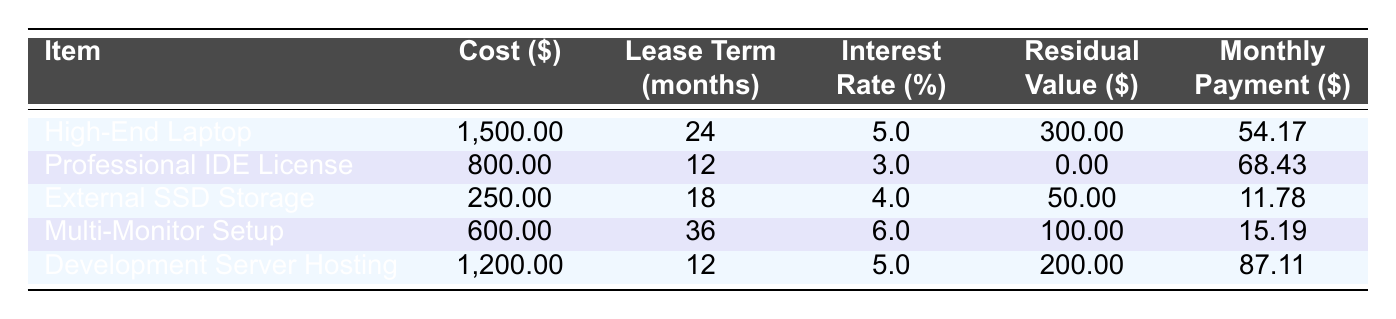What is the monthly payment for the High-End Laptop? The table lists the monthly payment for the High-End Laptop as 54.17. Simply refer to the corresponding row in the table for this item.
Answer: 54.17 What is the cost of the Professional IDE License? According to the table, the cost is clearly stated as 800.00. This information can be found directly in the relevant row.
Answer: 800.00 How many months is the lease term for the Multi-Monitor Setup? The lease term for the Multi-Monitor Setup is listed as 36 months. This information is directly obtainable from the corresponding row in the table.
Answer: 36 Is the residual value of the External SSD Storage greater than 40? The table shows the residual value for the External SSD Storage as 50.00, which is greater than 40. By checking the value in the table, we can confirm this fact.
Answer: Yes What is the average cost of all the equipment items listed? To find the average cost, sum the costs: 1500.00 + 800.00 + 250.00 + 600.00 + 1200.00 = 3350.00. Then divide by the number of items, which is 5: 3350.00 / 5 = 670.00. This calculation shows the average cost based on all listed items.
Answer: 670.00 Which item has the highest monthly payment, and what is that amount? By comparing the monthly payments, the Development Server Hosting has the highest payment listed as 87.11. This can be determined by reviewing the monthly payment column for each equipment item.
Answer: Development Server Hosting, 87.11 What is the total residual value of all the equipment? The total residual value can be calculated by adding the individual residual values: 300.00 + 0.00 + 50.00 + 100.00 + 200.00 = 650.00. This total is derived from the residual value column in the table.
Answer: 650.00 Are there any items with a lease term shorter than 18 months? The Professional IDE License has a lease term of 12 months and the Development Server Hosting has the same term of 12 months, both of which are shorter than 18 months. By reviewing the lease term column, we identify these items.
Answer: Yes What is the difference in monthly payments between the High-End Laptop and the Multi-Monitor Setup? The monthly payment for the High-End Laptop is 54.17 and for the Multi-Monitor Setup is 15.19. The difference is calculated as 54.17 - 15.19 = 38.98. This calculation involves subtracting the two payments from the table.
Answer: 38.98 